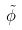Convert formula to latex. <formula><loc_0><loc_0><loc_500><loc_500>\tilde { \phi }</formula> 